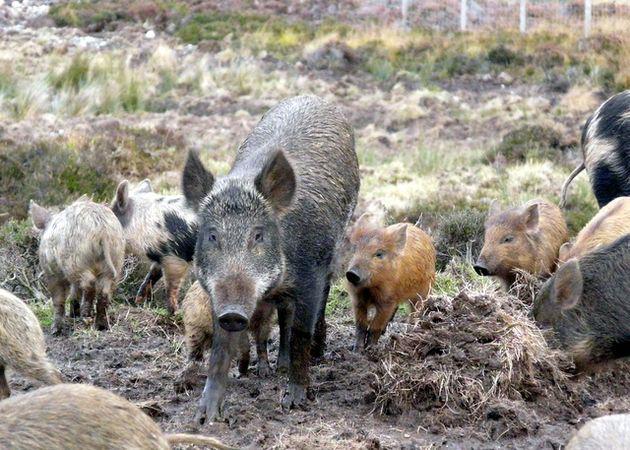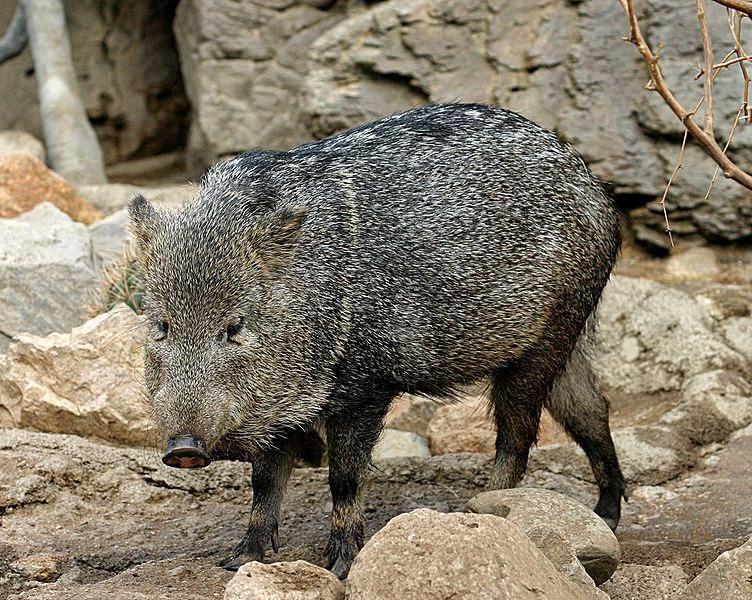The first image is the image on the left, the second image is the image on the right. For the images displayed, is the sentence "There are some piglets in the left image." factually correct? Answer yes or no. Yes. The first image is the image on the left, the second image is the image on the right. Given the left and right images, does the statement "a warthog is standing facing the camera with piglets near her" hold true? Answer yes or no. Yes. 